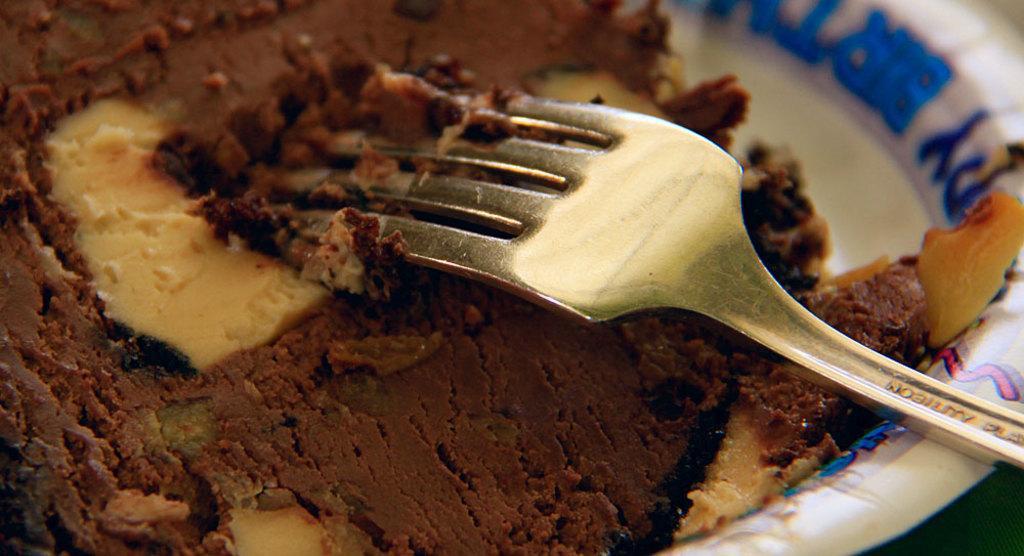Can you describe this image briefly? In this picture we can see a fork and food in the plate. 